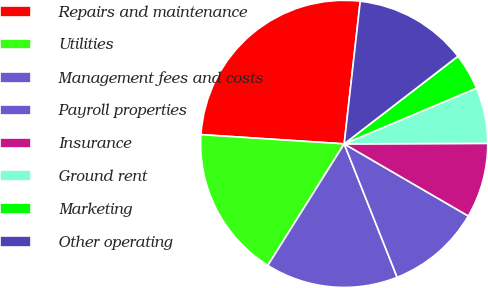Convert chart to OTSL. <chart><loc_0><loc_0><loc_500><loc_500><pie_chart><fcel>Repairs and maintenance<fcel>Utilities<fcel>Management fees and costs<fcel>Payroll properties<fcel>Insurance<fcel>Ground rent<fcel>Marketing<fcel>Other operating<nl><fcel>25.76%<fcel>17.1%<fcel>14.94%<fcel>10.61%<fcel>8.44%<fcel>6.28%<fcel>4.11%<fcel>12.77%<nl></chart> 